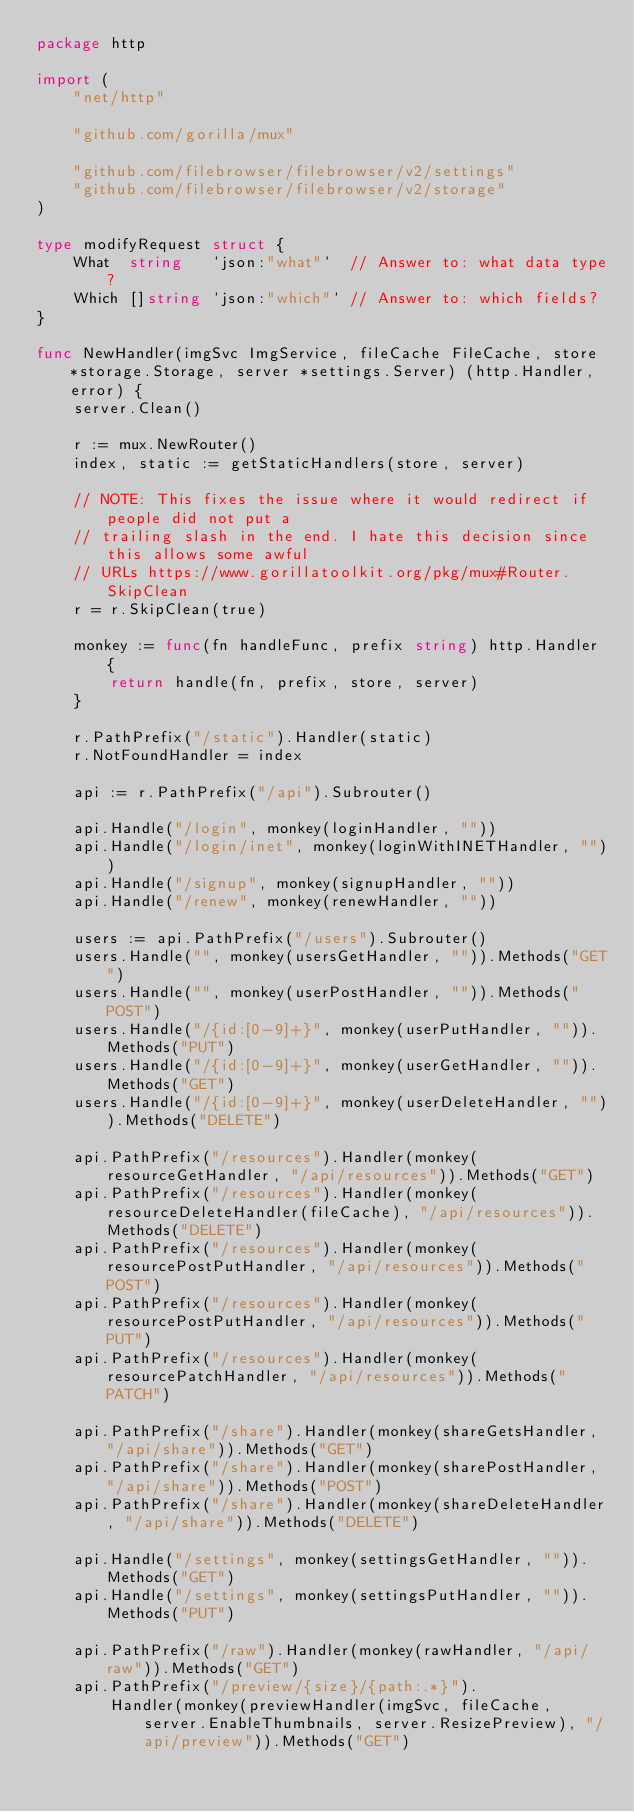Convert code to text. <code><loc_0><loc_0><loc_500><loc_500><_Go_>package http

import (
	"net/http"

	"github.com/gorilla/mux"

	"github.com/filebrowser/filebrowser/v2/settings"
	"github.com/filebrowser/filebrowser/v2/storage"
)

type modifyRequest struct {
	What  string   `json:"what"`  // Answer to: what data type?
	Which []string `json:"which"` // Answer to: which fields?
}

func NewHandler(imgSvc ImgService, fileCache FileCache, store *storage.Storage, server *settings.Server) (http.Handler, error) {
	server.Clean()

	r := mux.NewRouter()
	index, static := getStaticHandlers(store, server)

	// NOTE: This fixes the issue where it would redirect if people did not put a
	// trailing slash in the end. I hate this decision since this allows some awful
	// URLs https://www.gorillatoolkit.org/pkg/mux#Router.SkipClean
	r = r.SkipClean(true)

	monkey := func(fn handleFunc, prefix string) http.Handler {
		return handle(fn, prefix, store, server)
	}

	r.PathPrefix("/static").Handler(static)
	r.NotFoundHandler = index

	api := r.PathPrefix("/api").Subrouter()

	api.Handle("/login", monkey(loginHandler, ""))
	api.Handle("/login/inet", monkey(loginWithINETHandler, ""))
	api.Handle("/signup", monkey(signupHandler, ""))
	api.Handle("/renew", monkey(renewHandler, ""))

	users := api.PathPrefix("/users").Subrouter()
	users.Handle("", monkey(usersGetHandler, "")).Methods("GET")
	users.Handle("", monkey(userPostHandler, "")).Methods("POST")
	users.Handle("/{id:[0-9]+}", monkey(userPutHandler, "")).Methods("PUT")
	users.Handle("/{id:[0-9]+}", monkey(userGetHandler, "")).Methods("GET")
	users.Handle("/{id:[0-9]+}", monkey(userDeleteHandler, "")).Methods("DELETE")

	api.PathPrefix("/resources").Handler(monkey(resourceGetHandler, "/api/resources")).Methods("GET")
	api.PathPrefix("/resources").Handler(monkey(resourceDeleteHandler(fileCache), "/api/resources")).Methods("DELETE")
	api.PathPrefix("/resources").Handler(monkey(resourcePostPutHandler, "/api/resources")).Methods("POST")
	api.PathPrefix("/resources").Handler(monkey(resourcePostPutHandler, "/api/resources")).Methods("PUT")
	api.PathPrefix("/resources").Handler(monkey(resourcePatchHandler, "/api/resources")).Methods("PATCH")

	api.PathPrefix("/share").Handler(monkey(shareGetsHandler, "/api/share")).Methods("GET")
	api.PathPrefix("/share").Handler(monkey(sharePostHandler, "/api/share")).Methods("POST")
	api.PathPrefix("/share").Handler(monkey(shareDeleteHandler, "/api/share")).Methods("DELETE")

	api.Handle("/settings", monkey(settingsGetHandler, "")).Methods("GET")
	api.Handle("/settings", monkey(settingsPutHandler, "")).Methods("PUT")

	api.PathPrefix("/raw").Handler(monkey(rawHandler, "/api/raw")).Methods("GET")
	api.PathPrefix("/preview/{size}/{path:.*}").
		Handler(monkey(previewHandler(imgSvc, fileCache, server.EnableThumbnails, server.ResizePreview), "/api/preview")).Methods("GET")</code> 